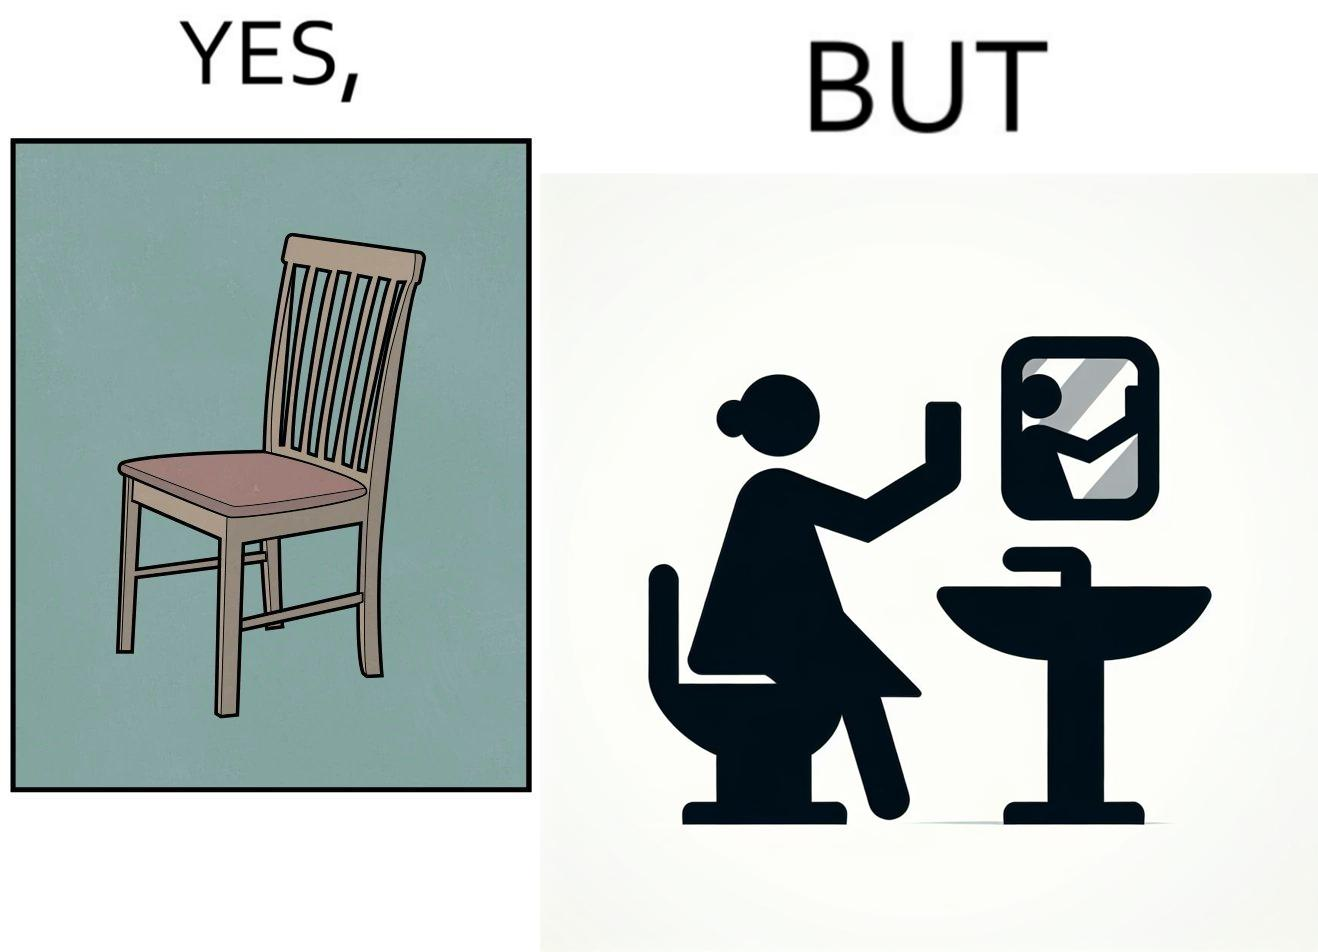Provide a description of this image. The image is ironical, as a woman is sitting by the sink taking a selfie using a mirror, while not using a chair that is actually meant for sitting. 